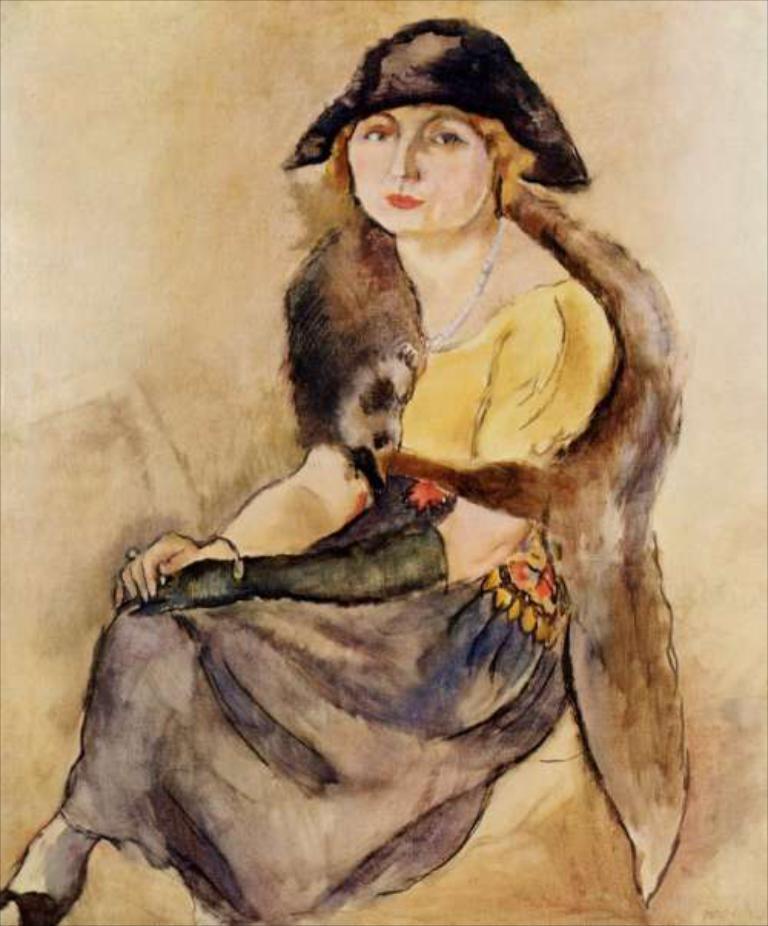Please provide a concise description of this image. In this image we can see the painting of a person and it looks like she is sitting and posing for a photo. 